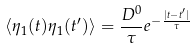<formula> <loc_0><loc_0><loc_500><loc_500>\langle \eta _ { 1 } ( t ) \eta _ { 1 } ( t ^ { \prime } ) \rangle = \frac { D ^ { 0 } } { \tau } e ^ { - \frac { | t - t ^ { \prime } | } { \tau } }</formula> 